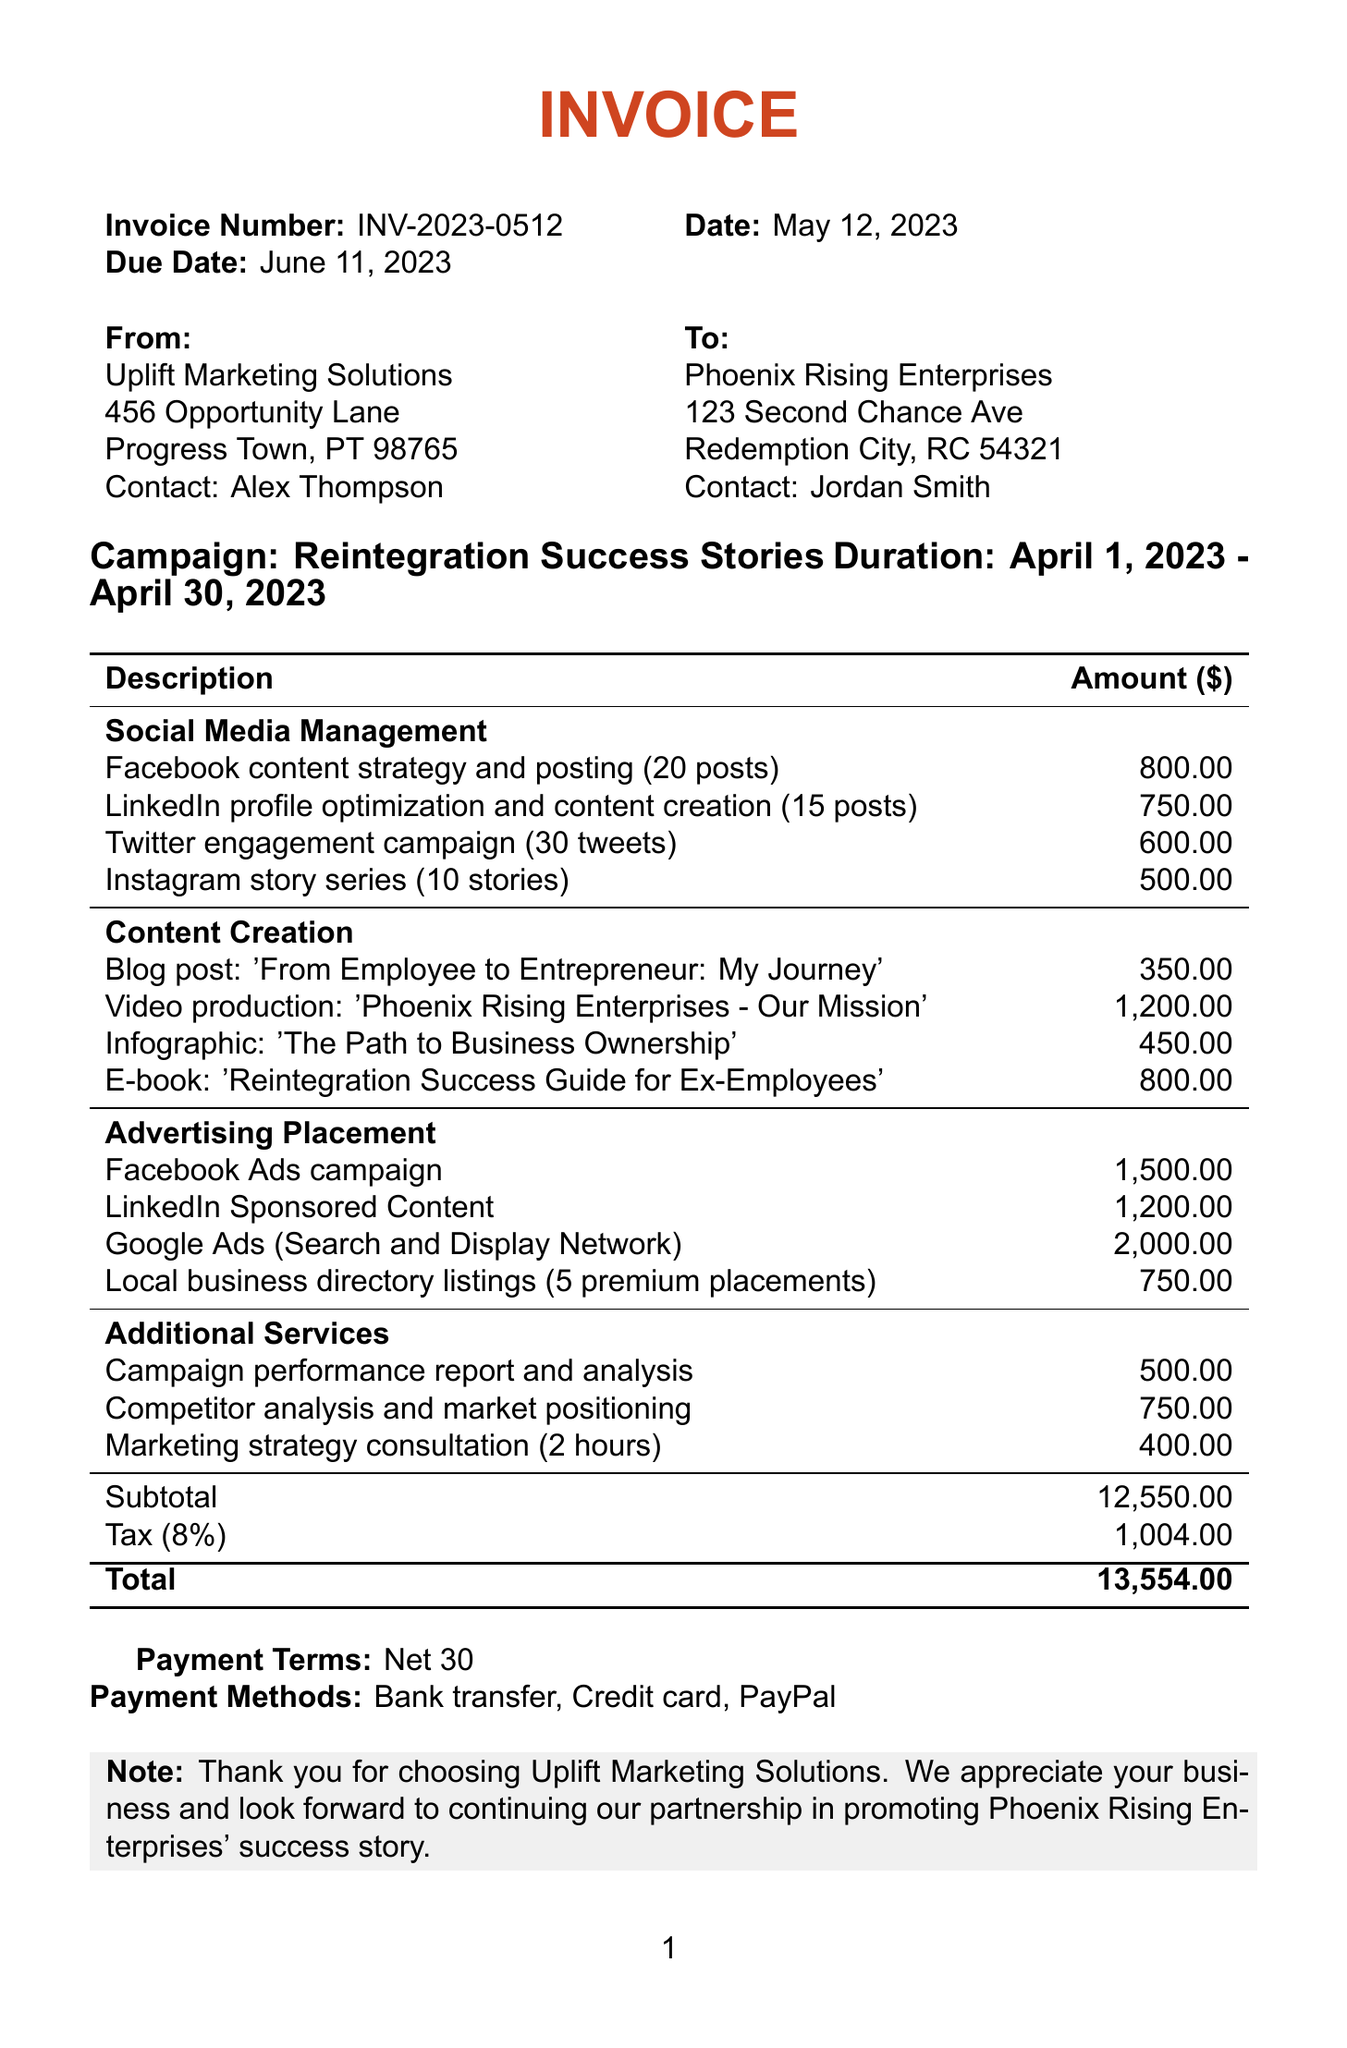What is the invoice number? The invoice number is provided at the top of the document, indicating a specific identifier for this invoice.
Answer: INV-2023-0512 When is the due date for the invoice? The due date is specified right after the invoice number and date, indicating when payment is expected.
Answer: June 11, 2023 Who is the contact person for the client? The client information section lists the contact person for Phoenix Rising Enterprises.
Answer: Jordan Smith What is the total amount due? The total amount is calculated at the end of the services list, showing the complete amount owed.
Answer: 13,554.00 How many posts were included in the Twitter engagement campaign? The service description for the Twitter engagement campaign specifies the number of tweets included.
Answer: 30 What is the cost for Facebook Ads campaign? The cost is listed under the Advertising Placement category, detailing the expenses for the advertising service.
Answer: 1,500.00 What is the duration of the marketing campaign? The duration is indicated below the campaign name, showing the timeframe for which the services were provided.
Answer: April 1, 2023 - April 30, 2023 What percentage is the tax rate on the subtotal? The tax amount is calculated based on the subtotal, and the rate is stated explicitly in the document.
Answer: 8% What type of document is this? The document title clearly states its purpose and type at the beginning.
Answer: Invoice 